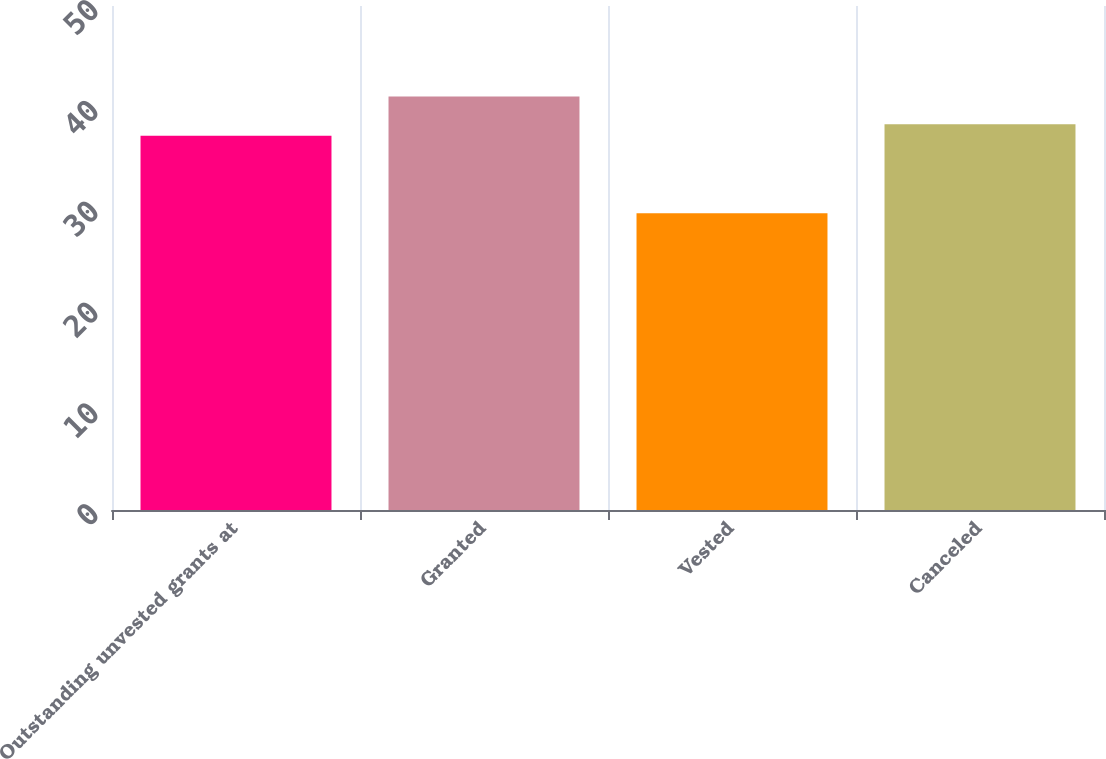<chart> <loc_0><loc_0><loc_500><loc_500><bar_chart><fcel>Outstanding unvested grants at<fcel>Granted<fcel>Vested<fcel>Canceled<nl><fcel>37.12<fcel>41.03<fcel>29.43<fcel>38.28<nl></chart> 